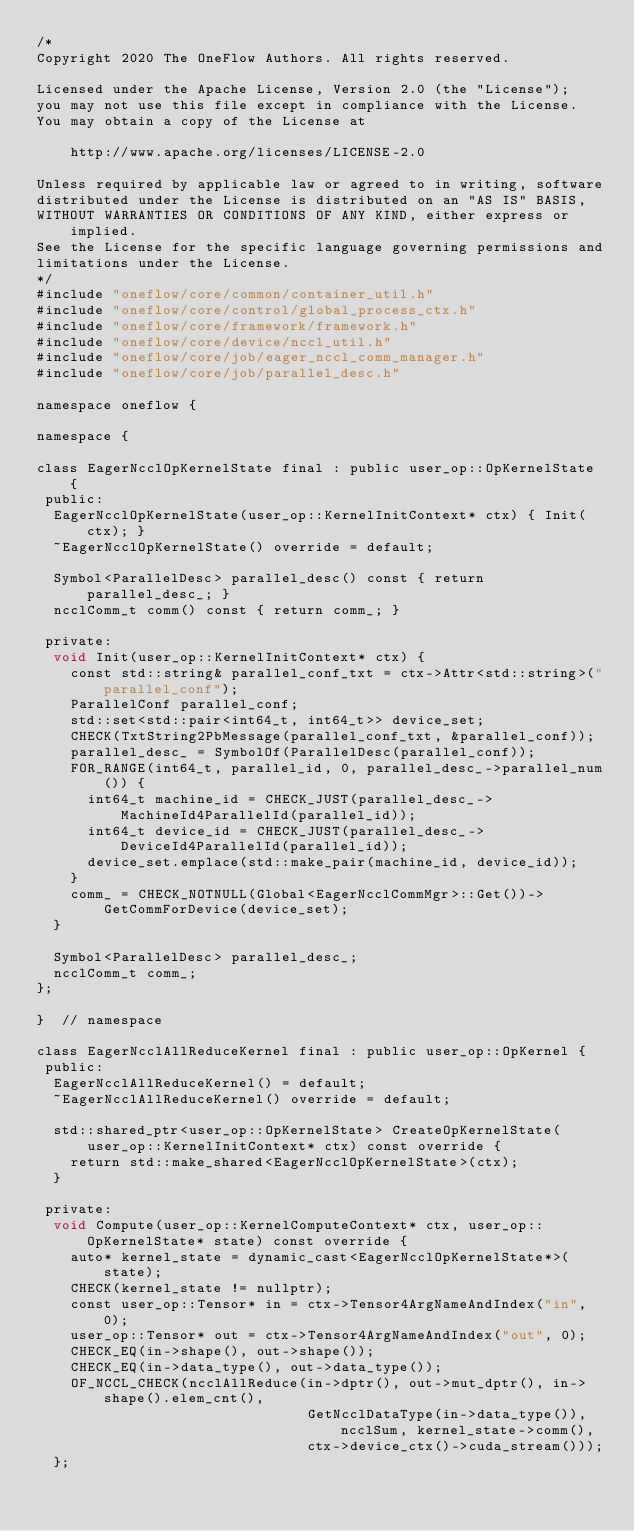<code> <loc_0><loc_0><loc_500><loc_500><_Cuda_>/*
Copyright 2020 The OneFlow Authors. All rights reserved.

Licensed under the Apache License, Version 2.0 (the "License");
you may not use this file except in compliance with the License.
You may obtain a copy of the License at

    http://www.apache.org/licenses/LICENSE-2.0

Unless required by applicable law or agreed to in writing, software
distributed under the License is distributed on an "AS IS" BASIS,
WITHOUT WARRANTIES OR CONDITIONS OF ANY KIND, either express or implied.
See the License for the specific language governing permissions and
limitations under the License.
*/
#include "oneflow/core/common/container_util.h"
#include "oneflow/core/control/global_process_ctx.h"
#include "oneflow/core/framework/framework.h"
#include "oneflow/core/device/nccl_util.h"
#include "oneflow/core/job/eager_nccl_comm_manager.h"
#include "oneflow/core/job/parallel_desc.h"

namespace oneflow {

namespace {

class EagerNcclOpKernelState final : public user_op::OpKernelState {
 public:
  EagerNcclOpKernelState(user_op::KernelInitContext* ctx) { Init(ctx); }
  ~EagerNcclOpKernelState() override = default;

  Symbol<ParallelDesc> parallel_desc() const { return parallel_desc_; }
  ncclComm_t comm() const { return comm_; }

 private:
  void Init(user_op::KernelInitContext* ctx) {
    const std::string& parallel_conf_txt = ctx->Attr<std::string>("parallel_conf");
    ParallelConf parallel_conf;
    std::set<std::pair<int64_t, int64_t>> device_set;
    CHECK(TxtString2PbMessage(parallel_conf_txt, &parallel_conf));
    parallel_desc_ = SymbolOf(ParallelDesc(parallel_conf));
    FOR_RANGE(int64_t, parallel_id, 0, parallel_desc_->parallel_num()) {
      int64_t machine_id = CHECK_JUST(parallel_desc_->MachineId4ParallelId(parallel_id));
      int64_t device_id = CHECK_JUST(parallel_desc_->DeviceId4ParallelId(parallel_id));
      device_set.emplace(std::make_pair(machine_id, device_id));
    }
    comm_ = CHECK_NOTNULL(Global<EagerNcclCommMgr>::Get())->GetCommForDevice(device_set);
  }

  Symbol<ParallelDesc> parallel_desc_;
  ncclComm_t comm_;
};

}  // namespace

class EagerNcclAllReduceKernel final : public user_op::OpKernel {
 public:
  EagerNcclAllReduceKernel() = default;
  ~EagerNcclAllReduceKernel() override = default;

  std::shared_ptr<user_op::OpKernelState> CreateOpKernelState(
      user_op::KernelInitContext* ctx) const override {
    return std::make_shared<EagerNcclOpKernelState>(ctx);
  }

 private:
  void Compute(user_op::KernelComputeContext* ctx, user_op::OpKernelState* state) const override {
    auto* kernel_state = dynamic_cast<EagerNcclOpKernelState*>(state);
    CHECK(kernel_state != nullptr);
    const user_op::Tensor* in = ctx->Tensor4ArgNameAndIndex("in", 0);
    user_op::Tensor* out = ctx->Tensor4ArgNameAndIndex("out", 0);
    CHECK_EQ(in->shape(), out->shape());
    CHECK_EQ(in->data_type(), out->data_type());
    OF_NCCL_CHECK(ncclAllReduce(in->dptr(), out->mut_dptr(), in->shape().elem_cnt(),
                                GetNcclDataType(in->data_type()), ncclSum, kernel_state->comm(),
                                ctx->device_ctx()->cuda_stream()));
  };</code> 